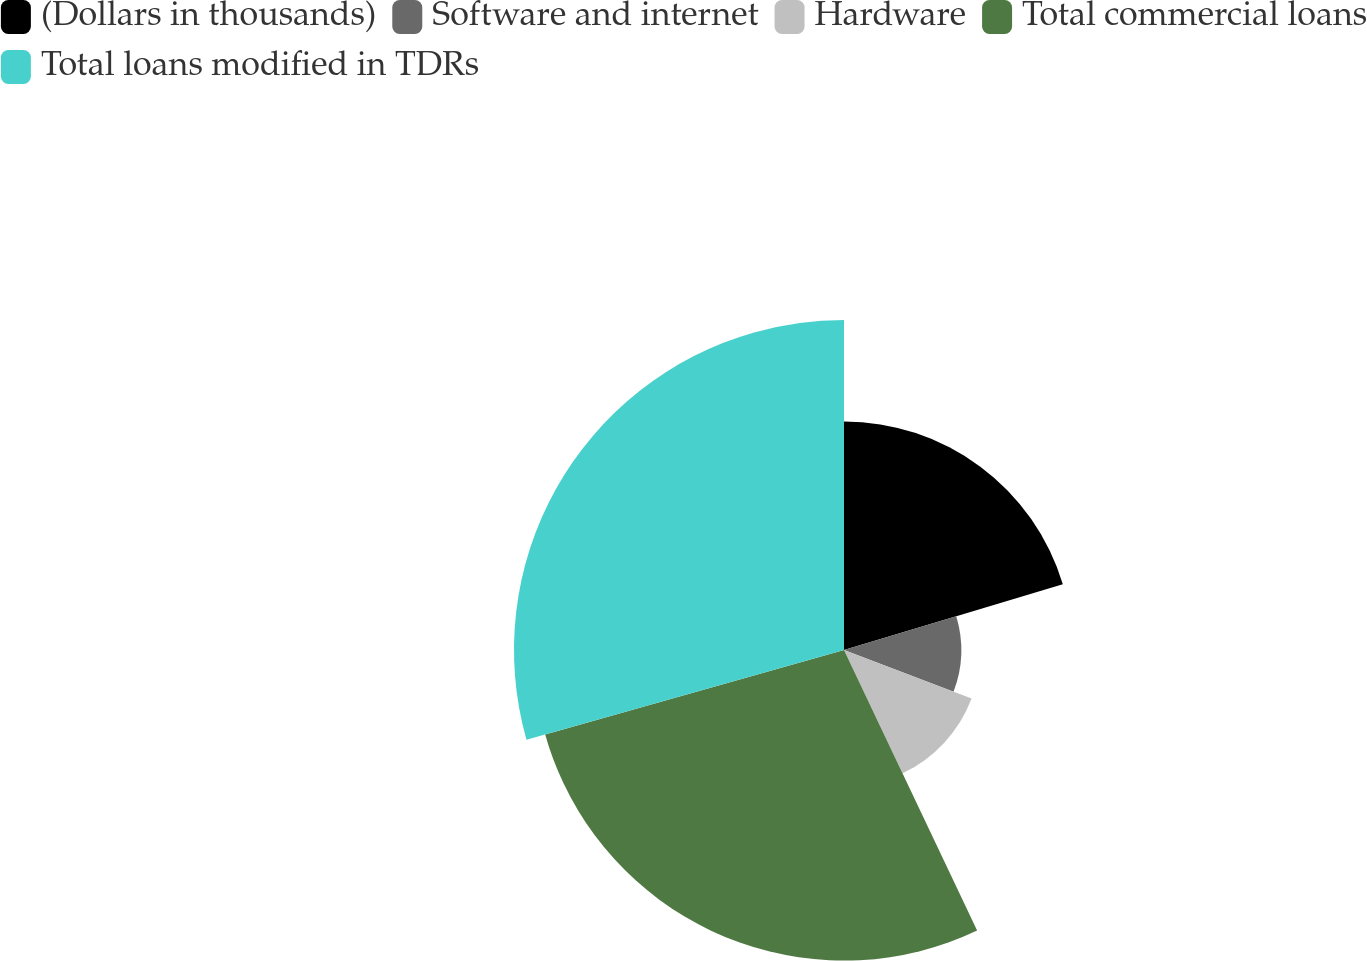Convert chart to OTSL. <chart><loc_0><loc_0><loc_500><loc_500><pie_chart><fcel>(Dollars in thousands)<fcel>Software and internet<fcel>Hardware<fcel>Total commercial loans<fcel>Total loans modified in TDRs<nl><fcel>20.35%<fcel>10.44%<fcel>12.16%<fcel>27.66%<fcel>29.39%<nl></chart> 